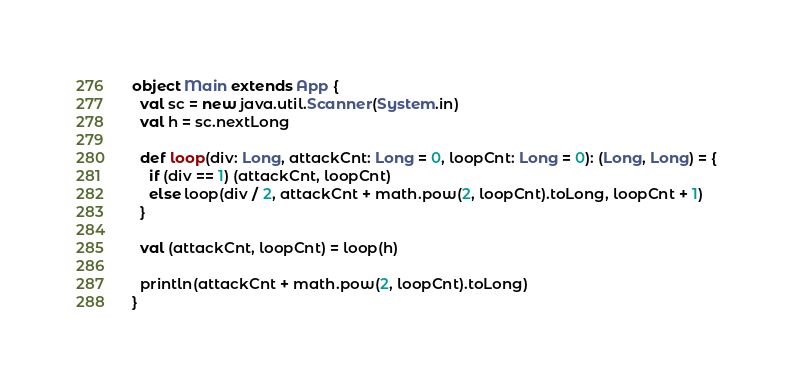Convert code to text. <code><loc_0><loc_0><loc_500><loc_500><_Scala_>object Main extends App {
  val sc = new java.util.Scanner(System.in)
  val h = sc.nextLong
  
  def loop(div: Long, attackCnt: Long = 0, loopCnt: Long = 0): (Long, Long) = {
    if (div == 1) (attackCnt, loopCnt)
    else loop(div / 2, attackCnt + math.pow(2, loopCnt).toLong, loopCnt + 1)
  }
  
  val (attackCnt, loopCnt) = loop(h)
  
  println(attackCnt + math.pow(2, loopCnt).toLong)
}</code> 